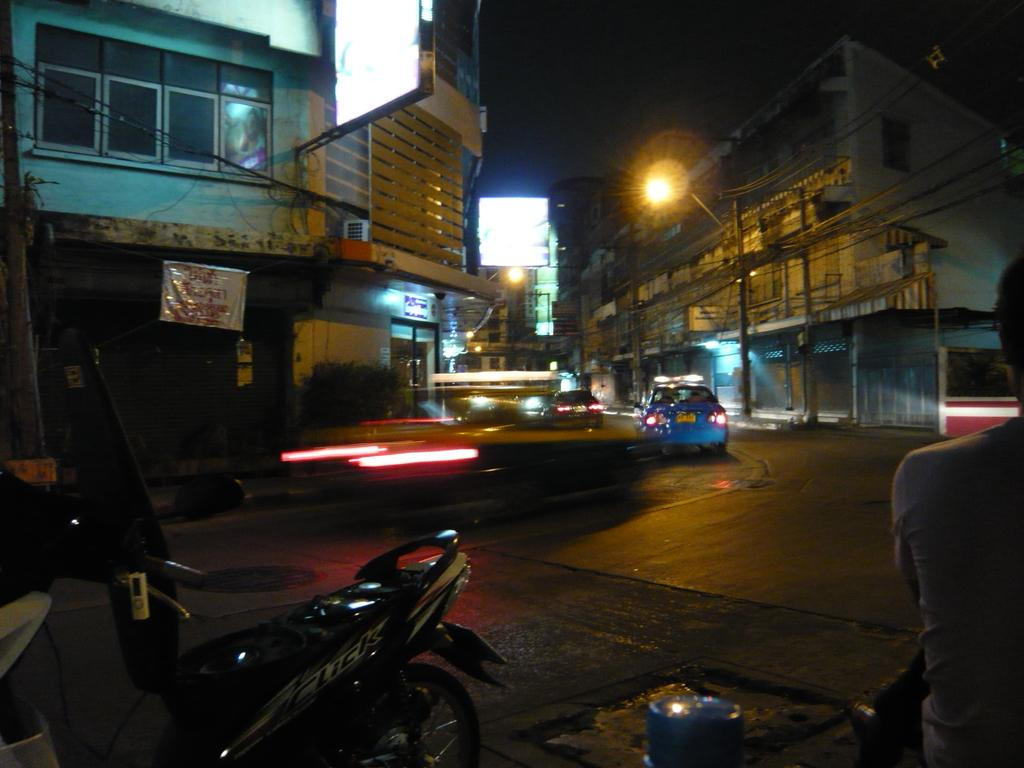What type of structures can be seen in the image? There are buildings in the image. What else is visible besides the buildings? There are vehicles, poles, wires, lights, doors, and a person in the image. What is the purpose of the poles and wires in the image? The poles and wires are likely used for supporting and transmitting electricity or communication signals. What can be seen hanging from the poles in the image? There are lights hanging from the poles in the image. What message or information is conveyed by the banner in the image? The banner in the image has text, but without knowing the text, we cannot determine the message or information it conveys. Can you see any straw in the image? There is no straw present in the image. Is there a cobweb visible in the image? There is no cobweb visible in the image. 